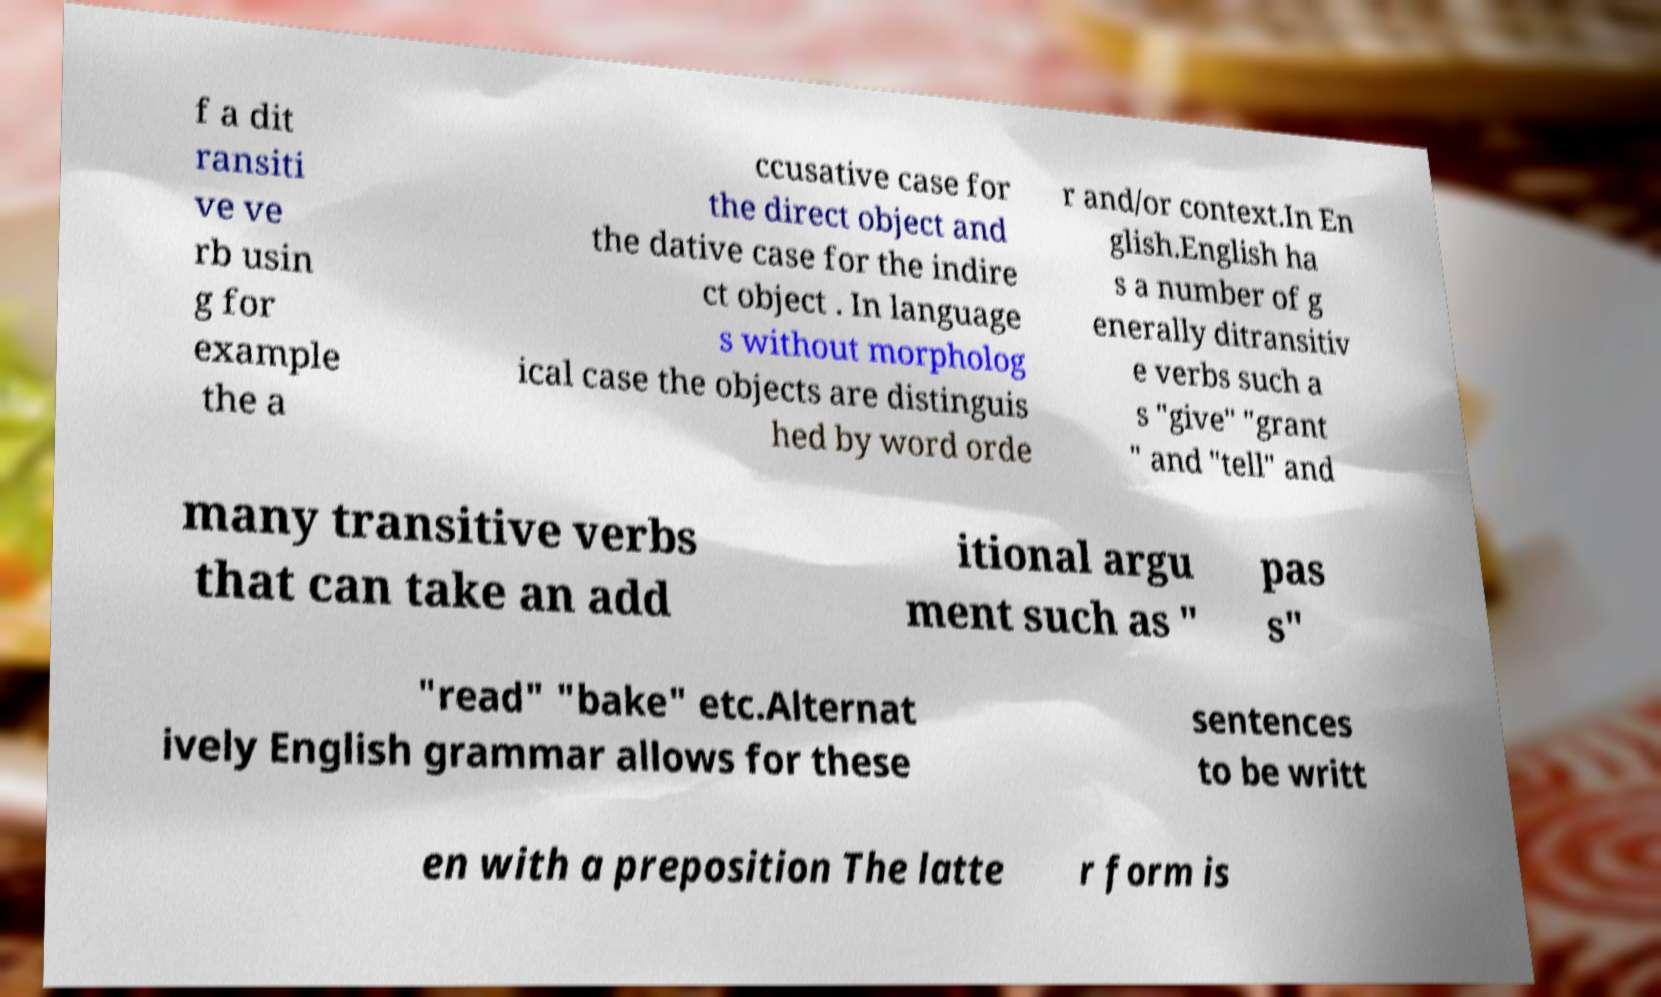Please identify and transcribe the text found in this image. f a dit ransiti ve ve rb usin g for example the a ccusative case for the direct object and the dative case for the indire ct object . In language s without morpholog ical case the objects are distinguis hed by word orde r and/or context.In En glish.English ha s a number of g enerally ditransitiv e verbs such a s "give" "grant " and "tell" and many transitive verbs that can take an add itional argu ment such as " pas s" "read" "bake" etc.Alternat ively English grammar allows for these sentences to be writt en with a preposition The latte r form is 